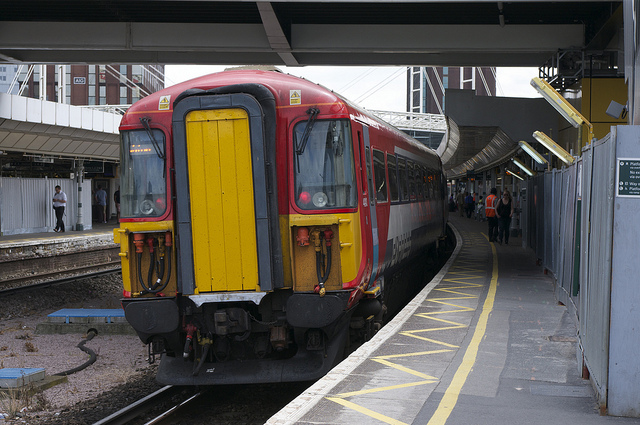<image>Which cartoon character's shirt does the zigzagging yellow line resemble? I am not sure. The zigzagging yellow line on the shirt can resemble various cartoon characters such as 'Charlie Brown', 'Flash', 'Wubbzy', or 'Curious George'. Which cartoon character's shirt does the zigzagging yellow line resemble? I don't know which cartoon character's shirt does the zigzagging yellow line resemble. It can be flash, wubbzy, charlie brown, curious george, vallados, donald duck or peanuts. 